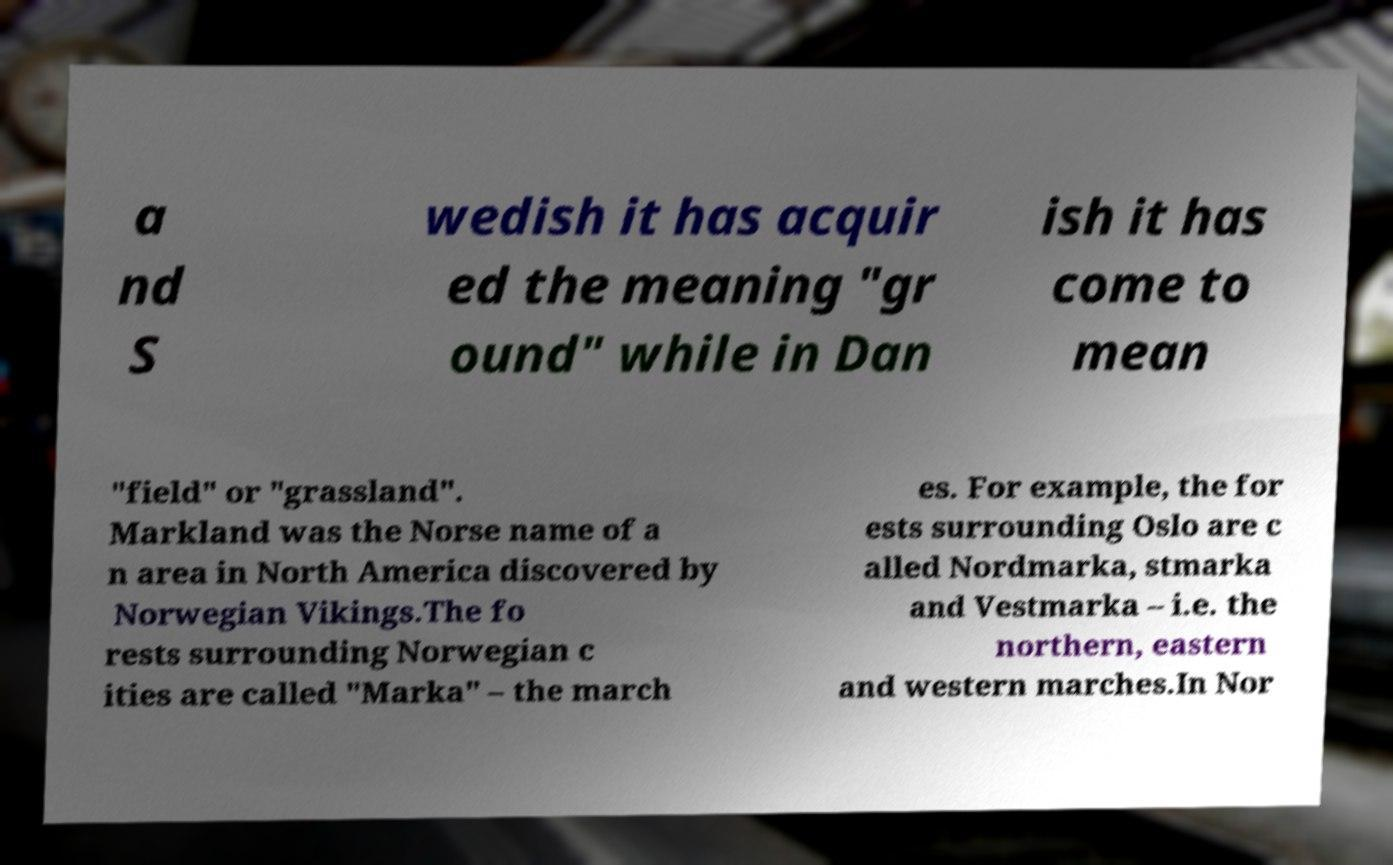What messages or text are displayed in this image? I need them in a readable, typed format. a nd S wedish it has acquir ed the meaning "gr ound" while in Dan ish it has come to mean "field" or "grassland". Markland was the Norse name of a n area in North America discovered by Norwegian Vikings.The fo rests surrounding Norwegian c ities are called "Marka" – the march es. For example, the for ests surrounding Oslo are c alled Nordmarka, stmarka and Vestmarka – i.e. the northern, eastern and western marches.In Nor 